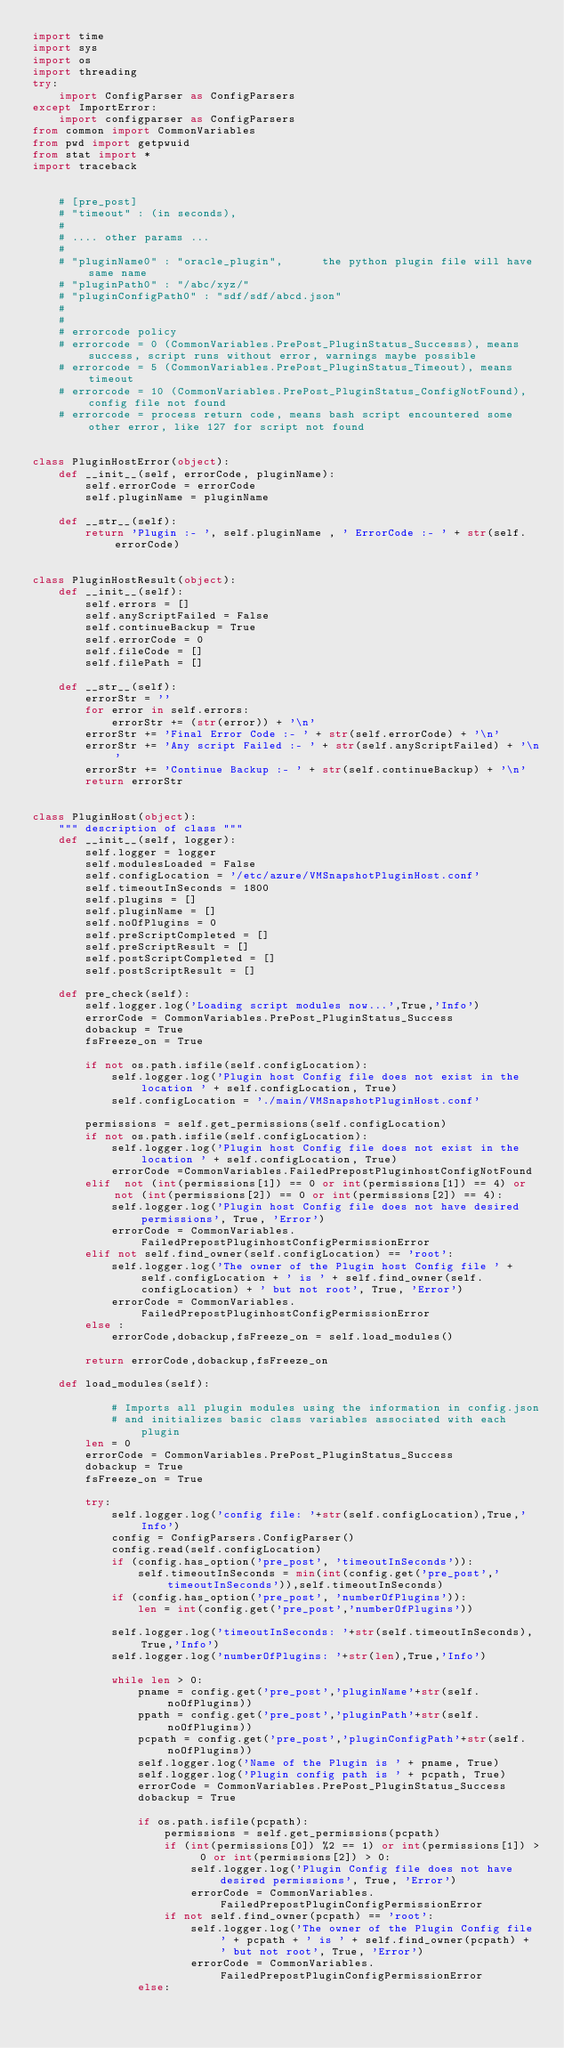Convert code to text. <code><loc_0><loc_0><loc_500><loc_500><_Python_>import time
import sys
import os
import threading
try:
    import ConfigParser as ConfigParsers
except ImportError:
    import configparser as ConfigParsers
from common import CommonVariables
from pwd import getpwuid
from stat import *
import traceback


    # [pre_post]
    # "timeout" : (in seconds),
    #
    # .... other params ...
    #
    # "pluginName0" : "oracle_plugin",      the python plugin file will have same name
    # "pluginPath0" : "/abc/xyz/"
    # "pluginConfigPath0" : "sdf/sdf/abcd.json"
    #
    #
    # errorcode policy
    # errorcode = 0 (CommonVariables.PrePost_PluginStatus_Successs), means success, script runs without error, warnings maybe possible
    # errorcode = 5 (CommonVariables.PrePost_PluginStatus_Timeout), means timeout
    # errorcode = 10 (CommonVariables.PrePost_PluginStatus_ConfigNotFound), config file not found
    # errorcode = process return code, means bash script encountered some other error, like 127 for script not found


class PluginHostError(object):
    def __init__(self, errorCode, pluginName):
        self.errorCode = errorCode
        self.pluginName = pluginName

    def __str__(self):
        return 'Plugin :- ', self.pluginName , ' ErrorCode :- ' + str(self.errorCode)


class PluginHostResult(object):
    def __init__(self):
        self.errors = []
        self.anyScriptFailed = False
        self.continueBackup = True
        self.errorCode = 0
        self.fileCode = []
        self.filePath = []

    def __str__(self):
        errorStr = ''
        for error in self.errors:
            errorStr += (str(error)) + '\n'
        errorStr += 'Final Error Code :- ' + str(self.errorCode) + '\n'
        errorStr += 'Any script Failed :- ' + str(self.anyScriptFailed) + '\n'
        errorStr += 'Continue Backup :- ' + str(self.continueBackup) + '\n'
        return errorStr


class PluginHost(object):
    """ description of class """
    def __init__(self, logger):
        self.logger = logger
        self.modulesLoaded = False
        self.configLocation = '/etc/azure/VMSnapshotPluginHost.conf'
        self.timeoutInSeconds = 1800
        self.plugins = []
        self.pluginName = []
        self.noOfPlugins = 0
        self.preScriptCompleted = []
        self.preScriptResult = []
        self.postScriptCompleted = []
        self.postScriptResult = []

    def pre_check(self):
        self.logger.log('Loading script modules now...',True,'Info')
        errorCode = CommonVariables.PrePost_PluginStatus_Success
        dobackup = True
        fsFreeze_on = True

        if not os.path.isfile(self.configLocation):
            self.logger.log('Plugin host Config file does not exist in the location ' + self.configLocation, True)
            self.configLocation = './main/VMSnapshotPluginHost.conf'
        
        permissions = self.get_permissions(self.configLocation)
        if not os.path.isfile(self.configLocation):
            self.logger.log('Plugin host Config file does not exist in the location ' + self.configLocation, True)
            errorCode =CommonVariables.FailedPrepostPluginhostConfigNotFound
        elif  not (int(permissions[1]) == 0 or int(permissions[1]) == 4) or not (int(permissions[2]) == 0 or int(permissions[2]) == 4):
            self.logger.log('Plugin host Config file does not have desired permissions', True, 'Error')
            errorCode = CommonVariables.FailedPrepostPluginhostConfigPermissionError
        elif not self.find_owner(self.configLocation) == 'root':
            self.logger.log('The owner of the Plugin host Config file ' + self.configLocation + ' is ' + self.find_owner(self.configLocation) + ' but not root', True, 'Error')
            errorCode = CommonVariables.FailedPrepostPluginhostConfigPermissionError
        else :
            errorCode,dobackup,fsFreeze_on = self.load_modules()

        return errorCode,dobackup,fsFreeze_on

    def load_modules(self):

            # Imports all plugin modules using the information in config.json
            # and initializes basic class variables associated with each plugin
        len = 0
        errorCode = CommonVariables.PrePost_PluginStatus_Success
        dobackup = True
        fsFreeze_on = True

        try:
            self.logger.log('config file: '+str(self.configLocation),True,'Info')
            config = ConfigParsers.ConfigParser()
            config.read(self.configLocation)
            if (config.has_option('pre_post', 'timeoutInSeconds')):
                self.timeoutInSeconds = min(int(config.get('pre_post','timeoutInSeconds')),self.timeoutInSeconds)
            if (config.has_option('pre_post', 'numberOfPlugins')):
                len = int(config.get('pre_post','numberOfPlugins'))

            self.logger.log('timeoutInSeconds: '+str(self.timeoutInSeconds),True,'Info')
            self.logger.log('numberOfPlugins: '+str(len),True,'Info')

            while len > 0:
                pname = config.get('pre_post','pluginName'+str(self.noOfPlugins))
                ppath = config.get('pre_post','pluginPath'+str(self.noOfPlugins))
                pcpath = config.get('pre_post','pluginConfigPath'+str(self.noOfPlugins))
                self.logger.log('Name of the Plugin is ' + pname, True)
                self.logger.log('Plugin config path is ' + pcpath, True)
                errorCode = CommonVariables.PrePost_PluginStatus_Success
                dobackup = True

                if os.path.isfile(pcpath):
                    permissions = self.get_permissions(pcpath)
                    if (int(permissions[0]) %2 == 1) or int(permissions[1]) > 0 or int(permissions[2]) > 0:
                        self.logger.log('Plugin Config file does not have desired permissions', True, 'Error')
                        errorCode = CommonVariables.FailedPrepostPluginConfigPermissionError
                    if not self.find_owner(pcpath) == 'root':
                        self.logger.log('The owner of the Plugin Config file ' + pcpath + ' is ' + self.find_owner(pcpath) + ' but not root', True, 'Error')
                        errorCode = CommonVariables.FailedPrepostPluginConfigPermissionError
                else:</code> 